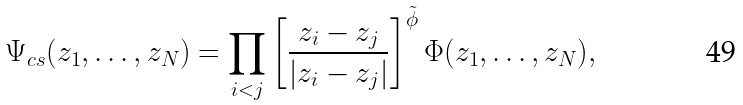Convert formula to latex. <formula><loc_0><loc_0><loc_500><loc_500>\Psi _ { c s } ( z _ { 1 } , \dots , z _ { N } ) = \prod _ { i < j } \left [ \frac { z _ { i } - z _ { j } } { | z _ { i } - z _ { j } | } \right ] ^ { \tilde { \phi } } \Phi ( z _ { 1 } , \dots , z _ { N } ) ,</formula> 